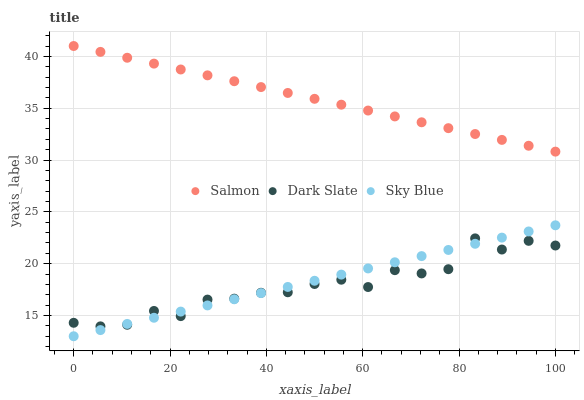Does Dark Slate have the minimum area under the curve?
Answer yes or no. Yes. Does Salmon have the maximum area under the curve?
Answer yes or no. Yes. Does Sky Blue have the minimum area under the curve?
Answer yes or no. No. Does Sky Blue have the maximum area under the curve?
Answer yes or no. No. Is Sky Blue the smoothest?
Answer yes or no. Yes. Is Dark Slate the roughest?
Answer yes or no. Yes. Is Salmon the smoothest?
Answer yes or no. No. Is Salmon the roughest?
Answer yes or no. No. Does Sky Blue have the lowest value?
Answer yes or no. Yes. Does Salmon have the lowest value?
Answer yes or no. No. Does Salmon have the highest value?
Answer yes or no. Yes. Does Sky Blue have the highest value?
Answer yes or no. No. Is Dark Slate less than Salmon?
Answer yes or no. Yes. Is Salmon greater than Dark Slate?
Answer yes or no. Yes. Does Dark Slate intersect Sky Blue?
Answer yes or no. Yes. Is Dark Slate less than Sky Blue?
Answer yes or no. No. Is Dark Slate greater than Sky Blue?
Answer yes or no. No. Does Dark Slate intersect Salmon?
Answer yes or no. No. 